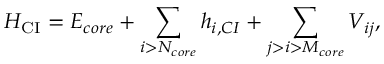Convert formula to latex. <formula><loc_0><loc_0><loc_500><loc_500>H _ { C I } = E _ { c o r e } + \sum _ { i > N _ { c o r e } } h _ { i , C I } + \sum _ { j > i > M _ { c o r e } } V _ { i j } ,</formula> 